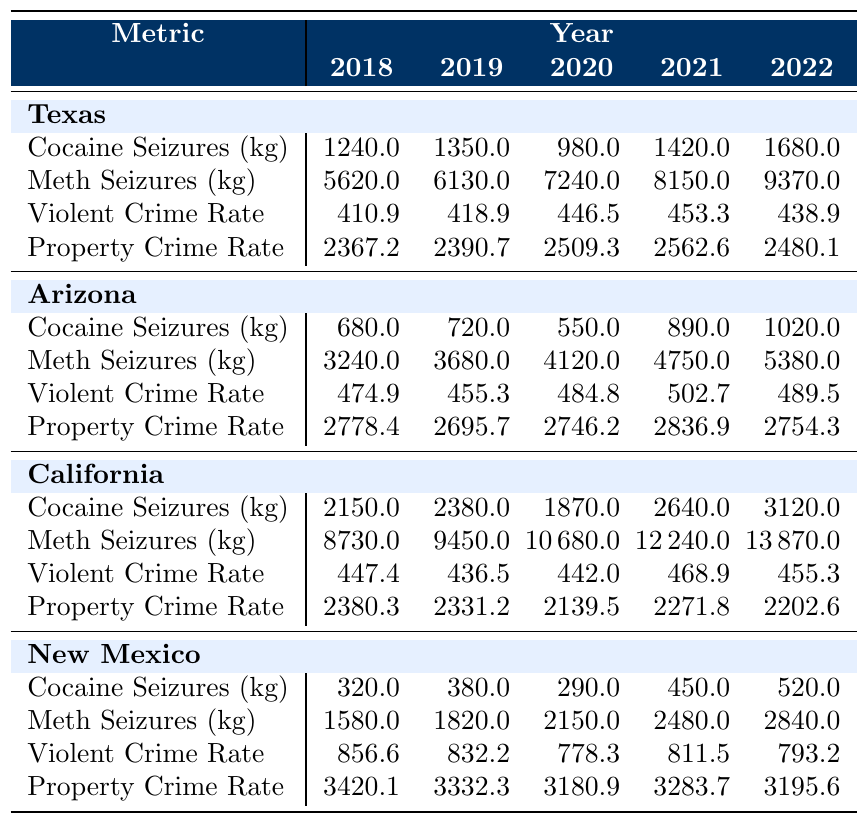What were the cocaine seizures in Texas in 2020? The table shows the cocaine seizures in Texas for each year, and for 2020, the value listed is 980 kg.
Answer: 980 kg What is the property crime rate in Arizona for 2021? From the table, the property crime rate for Arizona in 2021 is provided, which is 2836.9.
Answer: 2836.9 Which state had the highest meth seizures in 2022? By comparing the meth seizures across all states for 2022, California has the highest value listed at 13870 kg.
Answer: California What was the percentage increase in meth seizures in Texas from 2018 to 2022? The meth seizures in Texas rose from 5620 kg in 2018 to 9370 kg in 2022. To find the percentage increase: (9370 - 5620) / 5620 * 100 = 66.78%.
Answer: 66.78% True or False: The violent crime rate in New Mexico decreased from 2018 to 2022. By analyzing the violent crime rates for New Mexico from the table, they were 856.6 in 2018 and decreased to 793.2 in 2022, so the statement is true.
Answer: True What was the average cocaine seizure across all states in 2019? The cocaine seizures for 2019 are: Texas (1350 kg), Arizona (720 kg), California (2380 kg), and New Mexico (380 kg). Summing these gives 1350 + 720 + 2380 + 380 = 4830 kg. The average is 4830 / 4 = 1207.5 kg.
Answer: 1207.5 kg What is the difference in violent crime rates between Texas and California in 2022? The violent crime rate for Texas in 2022 is 438.9 and for California is 455.3. The difference is 455.3 - 438.9 = 16.4.
Answer: 16.4 What is the overall trend in property crime rates in California from 2018 to 2022? By examining the property crime rates for California: 2380.3 (2018), 2331.2 (2019), 2139.5 (2020), 2271.8 (2021), and 2202.6 (2022), we see fluctuations, but the overall trend is a decrease followed by a slight recovery in the last two years.
Answer: Fluctuating decrease What were the total violent crime rates for all states in 2020? The violent crime rates for 2020 are Texas (446.5), Arizona (484.8), California (442.0), and New Mexico (778.3). Summing these gives 446.5 + 484.8 + 442.0 + 778.3 = 2151.6.
Answer: 2151.6 